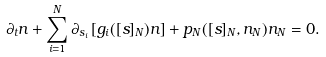<formula> <loc_0><loc_0><loc_500><loc_500>\partial _ { t } n + \sum _ { i = 1 } ^ { N } \partial _ { s _ { i } } \left [ g _ { i } ( [ s ] _ { N } ) n \right ] + p _ { N } ( [ s ] _ { N } , n _ { N } ) n _ { N } = 0 .</formula> 